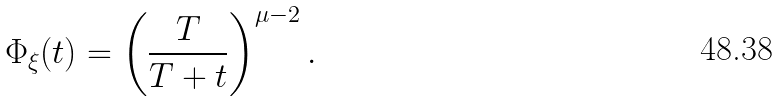<formula> <loc_0><loc_0><loc_500><loc_500>\Phi _ { \xi } ( t ) = \left ( \frac { T } { T + t } \right ) ^ { \mu - 2 } .</formula> 